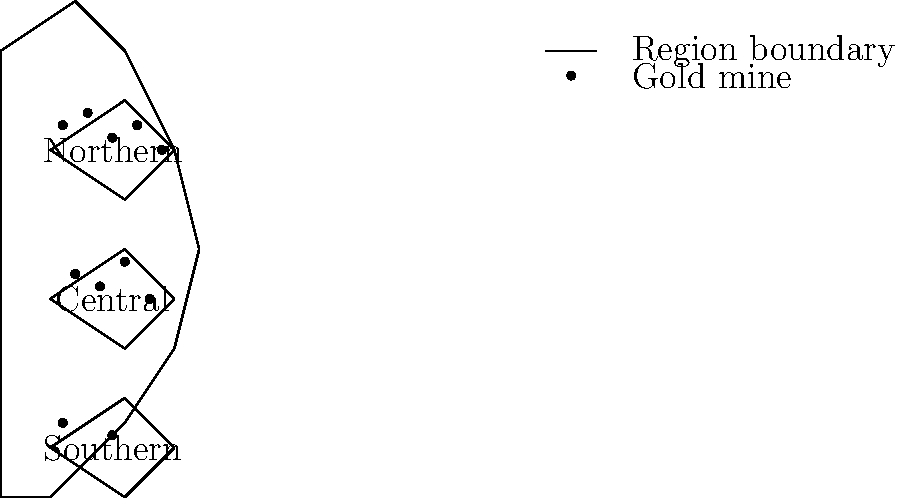Based on the map of California showing the distribution of gold mines during the Gold Rush era, which region had the highest concentration of gold mines, and how might this have influenced the development of California's economy and infrastructure during this period? To answer this question, let's analyze the map step-by-step:

1. The map shows California divided into three regions: Northern, Central, and Southern.

2. Gold mine distribution:
   - Northern region: 5 gold mines
   - Central region: 4 gold mines
   - Southern region: 2 gold mines

3. Clearly, the Northern region has the highest concentration of gold mines.

4. Impact on California's economy and infrastructure:

   a) Population growth: The Northern region likely experienced a significant population boom as prospectors and miners flocked to the area.

   b) Urban development: Towns and cities would have sprung up rapidly in the Northern region to support the mining industry and growing population.

   c) Transportation infrastructure: Roads, railways, and ports would have been developed first in the Northern region to facilitate the movement of people, supplies, and gold.

   d) Economic diversification: As the gold economy grew, supporting industries such as agriculture, manufacturing, and services would have developed more quickly in the Northern region.

   e) Wealth concentration: The Northern region would have seen a concentration of wealth, leading to faster development of financial institutions and services.

   f) Political influence: The economic importance of the Northern region may have translated into greater political influence in the early days of California's statehood.

   g) Uneven development: The concentration of gold mines in the North likely led to uneven development across the state, with the Southern region potentially lagging behind initially.

5. Long-term effects: This initial concentration of gold mines in the Northern region may have set the stage for the future economic geography of California, influencing patterns of development that persist to this day.
Answer: Northern region; led to rapid population growth, urban development, and infrastructure expansion in Northern California, creating uneven development across the state. 